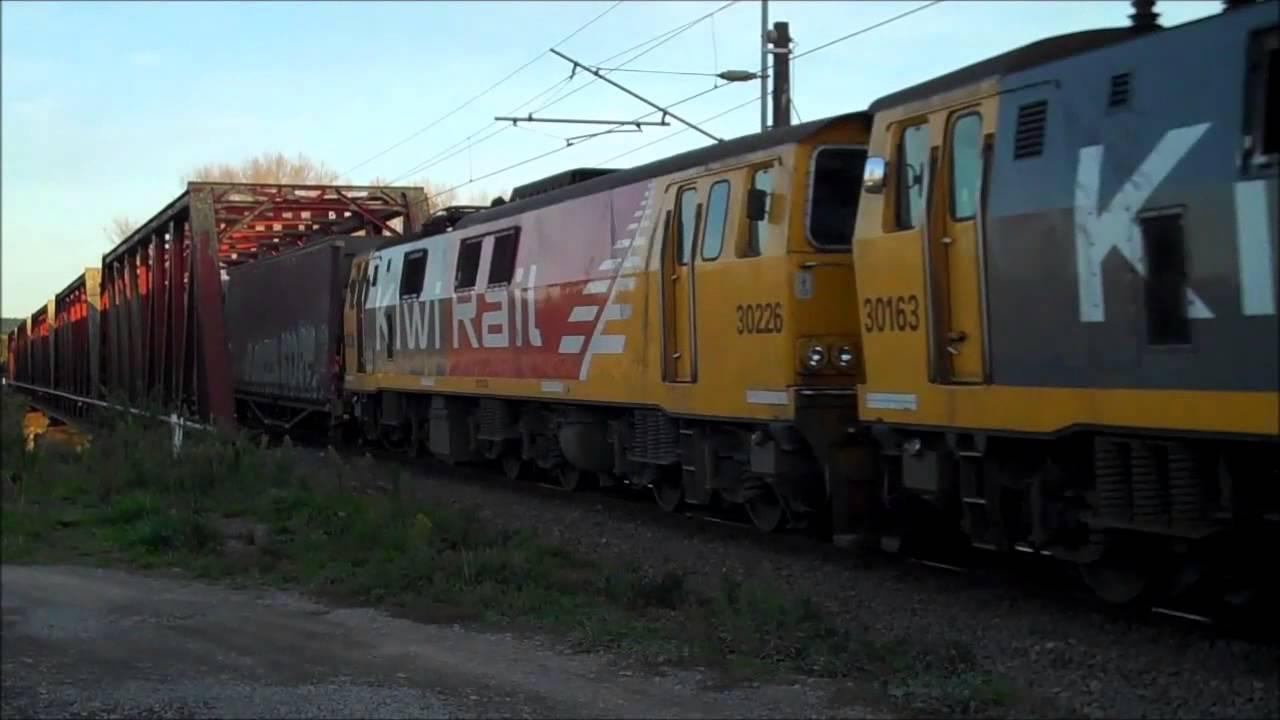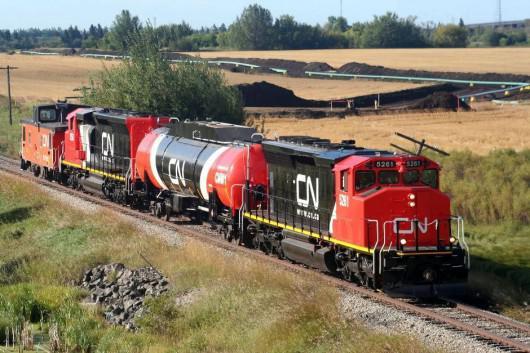The first image is the image on the left, the second image is the image on the right. Given the left and right images, does the statement "read trains are facing the left of the image" hold true? Answer yes or no. No. The first image is the image on the left, the second image is the image on the right. Examine the images to the left and right. Is the description "The engines in both images are have some red color and are facing to the left." accurate? Answer yes or no. No. 